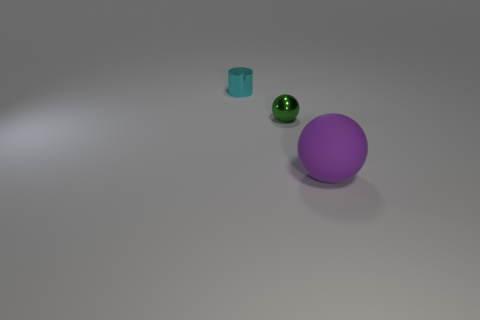What number of cyan cylinders have the same material as the small cyan thing?
Ensure brevity in your answer.  0. Are there fewer matte objects in front of the small green metallic ball than large blue cylinders?
Keep it short and to the point. No. There is a object behind the tiny object that is in front of the cyan metal object; what is its size?
Your answer should be very brief. Small. Do the small cylinder and the tiny object to the right of the small cyan cylinder have the same color?
Provide a succinct answer. No. There is a ball that is the same size as the cyan object; what is its material?
Give a very brief answer. Metal. Is the number of cyan shiny cylinders behind the big sphere less than the number of big objects right of the tiny green object?
Offer a very short reply. No. There is a tiny object behind the sphere that is left of the matte object; what is its shape?
Your answer should be compact. Cylinder. Are any big yellow things visible?
Keep it short and to the point. No. There is a ball that is behind the purple matte thing; what is its color?
Keep it short and to the point. Green. Are there any big purple spheres behind the large purple matte object?
Provide a succinct answer. No. 